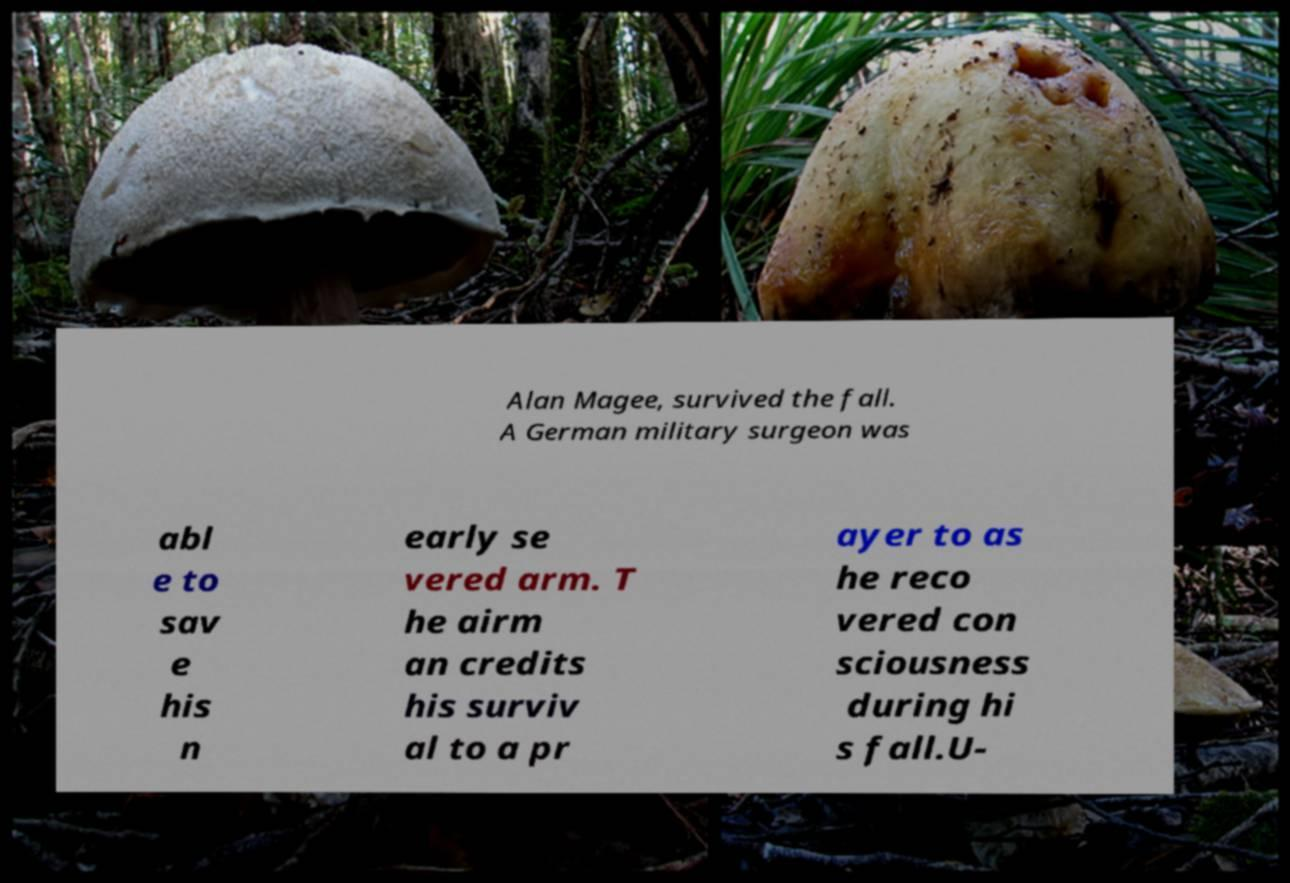Could you extract and type out the text from this image? Alan Magee, survived the fall. A German military surgeon was abl e to sav e his n early se vered arm. T he airm an credits his surviv al to a pr ayer to as he reco vered con sciousness during hi s fall.U- 